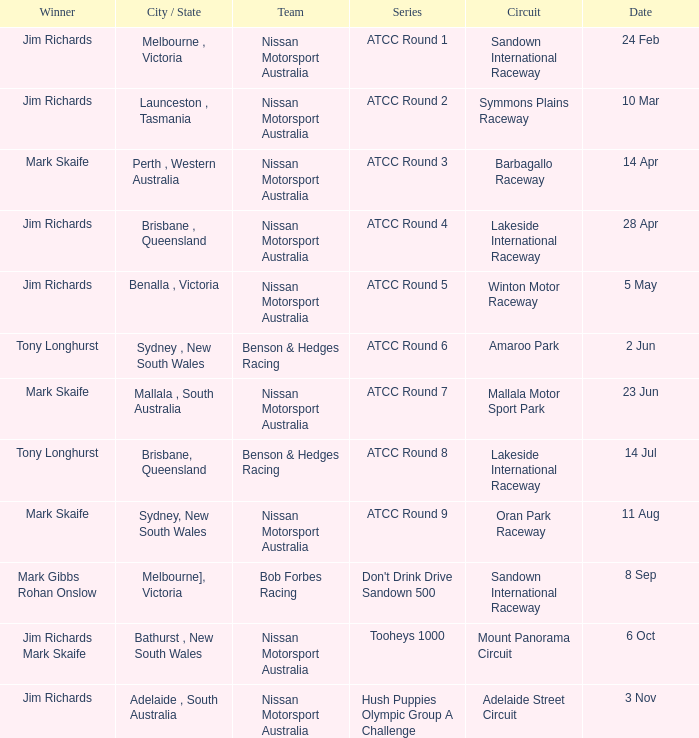What is the Circuit in the ATCC Round 1 Series with Winner Jim Richards? Sandown International Raceway. 